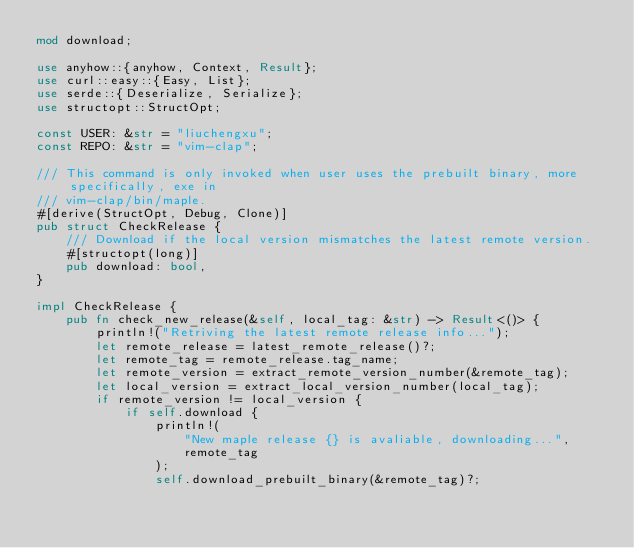<code> <loc_0><loc_0><loc_500><loc_500><_Rust_>mod download;

use anyhow::{anyhow, Context, Result};
use curl::easy::{Easy, List};
use serde::{Deserialize, Serialize};
use structopt::StructOpt;

const USER: &str = "liuchengxu";
const REPO: &str = "vim-clap";

/// This command is only invoked when user uses the prebuilt binary, more specifically, exe in
/// vim-clap/bin/maple.
#[derive(StructOpt, Debug, Clone)]
pub struct CheckRelease {
    /// Download if the local version mismatches the latest remote version.
    #[structopt(long)]
    pub download: bool,
}

impl CheckRelease {
    pub fn check_new_release(&self, local_tag: &str) -> Result<()> {
        println!("Retriving the latest remote release info...");
        let remote_release = latest_remote_release()?;
        let remote_tag = remote_release.tag_name;
        let remote_version = extract_remote_version_number(&remote_tag);
        let local_version = extract_local_version_number(local_tag);
        if remote_version != local_version {
            if self.download {
                println!(
                    "New maple release {} is avaliable, downloading...",
                    remote_tag
                );
                self.download_prebuilt_binary(&remote_tag)?;</code> 